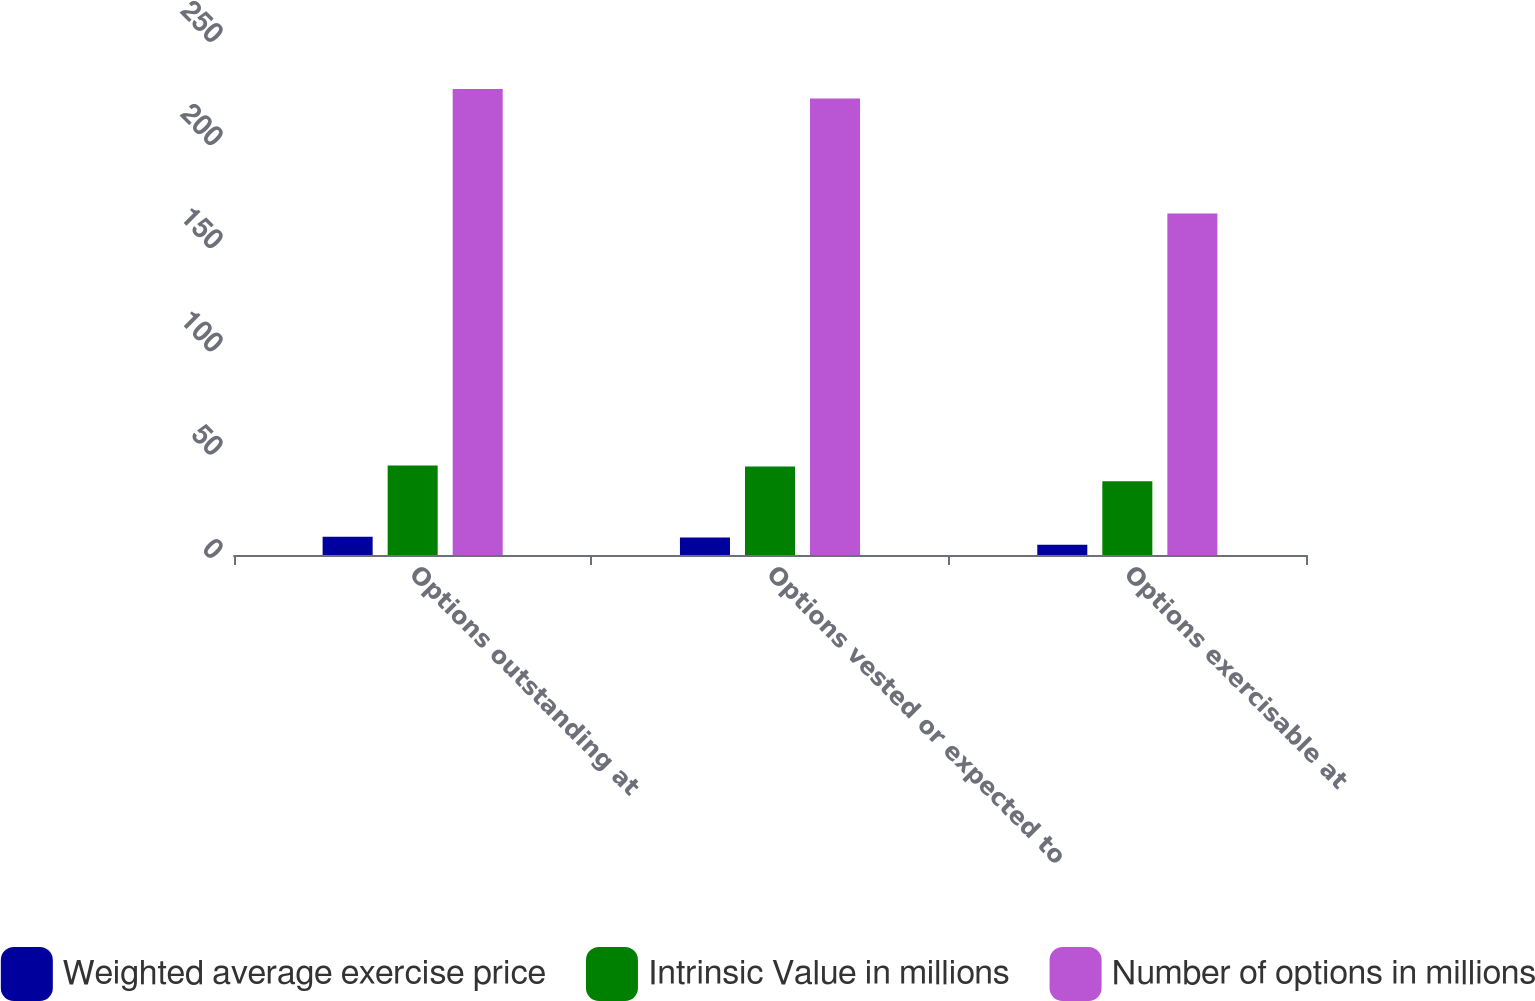<chart> <loc_0><loc_0><loc_500><loc_500><stacked_bar_chart><ecel><fcel>Options outstanding at<fcel>Options vested or expected to<fcel>Options exercisable at<nl><fcel>Weighted average exercise price<fcel>8.8<fcel>8.5<fcel>5<nl><fcel>Intrinsic Value in millions<fcel>43.31<fcel>42.86<fcel>35.79<nl><fcel>Number of options in millions<fcel>225.8<fcel>221.2<fcel>165.5<nl></chart> 